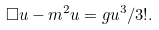<formula> <loc_0><loc_0><loc_500><loc_500>\Box u - m ^ { 2 } u = g u ^ { 3 } / 3 ! .</formula> 